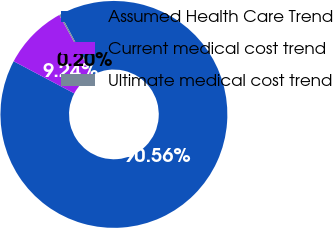Convert chart to OTSL. <chart><loc_0><loc_0><loc_500><loc_500><pie_chart><fcel>Assumed Health Care Trend<fcel>Current medical cost trend<fcel>Ultimate medical cost trend<nl><fcel>90.56%<fcel>9.24%<fcel>0.2%<nl></chart> 